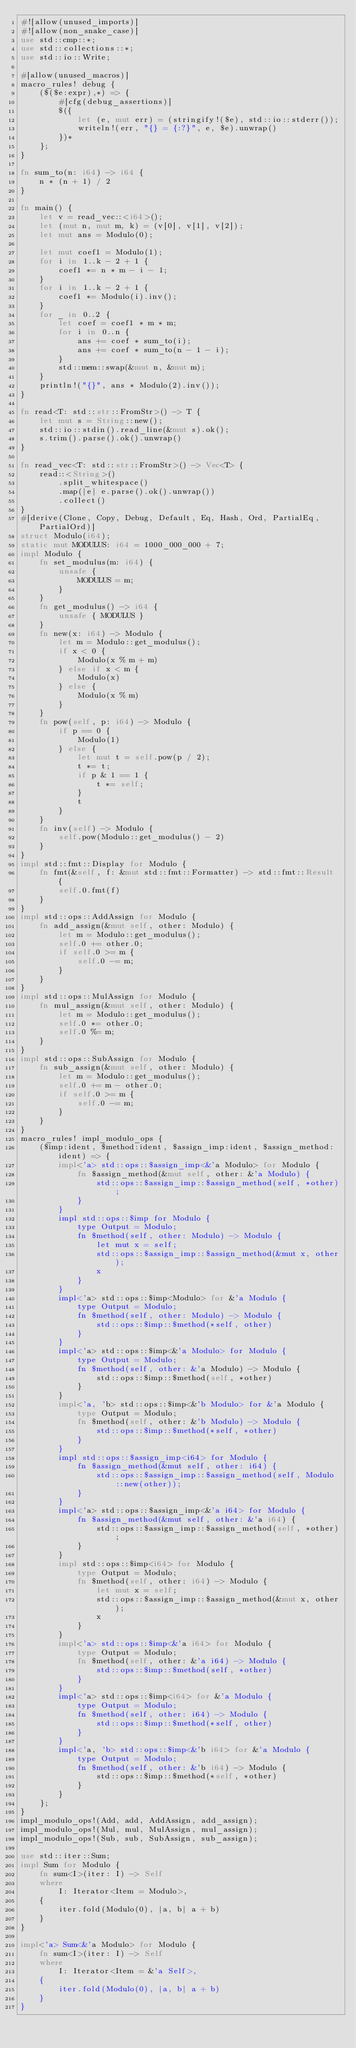Convert code to text. <code><loc_0><loc_0><loc_500><loc_500><_Rust_>#![allow(unused_imports)]
#![allow(non_snake_case)]
use std::cmp::*;
use std::collections::*;
use std::io::Write;

#[allow(unused_macros)]
macro_rules! debug {
    ($($e:expr),*) => {
        #[cfg(debug_assertions)]
        $({
            let (e, mut err) = (stringify!($e), std::io::stderr());
            writeln!(err, "{} = {:?}", e, $e).unwrap()
        })*
    };
}

fn sum_to(n: i64) -> i64 {
    n * (n + 1) / 2
}

fn main() {
    let v = read_vec::<i64>();
    let (mut n, mut m, k) = (v[0], v[1], v[2]);
    let mut ans = Modulo(0);

    let mut coef1 = Modulo(1);
    for i in 1..k - 2 + 1 {
        coef1 *= n * m - i - 1;
    }
    for i in 1..k - 2 + 1 {
        coef1 *= Modulo(i).inv();
    }
    for _ in 0..2 {
        let coef = coef1 * m * m;
        for i in 0..n {
            ans += coef * sum_to(i);
            ans += coef * sum_to(n - 1 - i);
        }
        std::mem::swap(&mut n, &mut m);
    }
    println!("{}", ans * Modulo(2).inv());
}

fn read<T: std::str::FromStr>() -> T {
    let mut s = String::new();
    std::io::stdin().read_line(&mut s).ok();
    s.trim().parse().ok().unwrap()
}

fn read_vec<T: std::str::FromStr>() -> Vec<T> {
    read::<String>()
        .split_whitespace()
        .map(|e| e.parse().ok().unwrap())
        .collect()
}
#[derive(Clone, Copy, Debug, Default, Eq, Hash, Ord, PartialEq, PartialOrd)]
struct Modulo(i64);
static mut MODULUS: i64 = 1000_000_000 + 7;
impl Modulo {
    fn set_modulus(m: i64) {
        unsafe {
            MODULUS = m;
        }
    }
    fn get_modulus() -> i64 {
        unsafe { MODULUS }
    }
    fn new(x: i64) -> Modulo {
        let m = Modulo::get_modulus();
        if x < 0 {
            Modulo(x % m + m)
        } else if x < m {
            Modulo(x)
        } else {
            Modulo(x % m)
        }
    }
    fn pow(self, p: i64) -> Modulo {
        if p == 0 {
            Modulo(1)
        } else {
            let mut t = self.pow(p / 2);
            t *= t;
            if p & 1 == 1 {
                t *= self;
            }
            t
        }
    }
    fn inv(self) -> Modulo {
        self.pow(Modulo::get_modulus() - 2)
    }
}
impl std::fmt::Display for Modulo {
    fn fmt(&self, f: &mut std::fmt::Formatter) -> std::fmt::Result {
        self.0.fmt(f)
    }
}
impl std::ops::AddAssign for Modulo {
    fn add_assign(&mut self, other: Modulo) {
        let m = Modulo::get_modulus();
        self.0 += other.0;
        if self.0 >= m {
            self.0 -= m;
        }
    }
}
impl std::ops::MulAssign for Modulo {
    fn mul_assign(&mut self, other: Modulo) {
        let m = Modulo::get_modulus();
        self.0 *= other.0;
        self.0 %= m;
    }
}
impl std::ops::SubAssign for Modulo {
    fn sub_assign(&mut self, other: Modulo) {
        let m = Modulo::get_modulus();
        self.0 += m - other.0;
        if self.0 >= m {
            self.0 -= m;
        }
    }
}
macro_rules! impl_modulo_ops {
    ($imp:ident, $method:ident, $assign_imp:ident, $assign_method:ident) => {
        impl<'a> std::ops::$assign_imp<&'a Modulo> for Modulo {
            fn $assign_method(&mut self, other: &'a Modulo) {
                std::ops::$assign_imp::$assign_method(self, *other);
            }
        }
        impl std::ops::$imp for Modulo {
            type Output = Modulo;
            fn $method(self, other: Modulo) -> Modulo {
                let mut x = self;
                std::ops::$assign_imp::$assign_method(&mut x, other);
                x
            }
        }
        impl<'a> std::ops::$imp<Modulo> for &'a Modulo {
            type Output = Modulo;
            fn $method(self, other: Modulo) -> Modulo {
                std::ops::$imp::$method(*self, other)
            }
        }
        impl<'a> std::ops::$imp<&'a Modulo> for Modulo {
            type Output = Modulo;
            fn $method(self, other: &'a Modulo) -> Modulo {
                std::ops::$imp::$method(self, *other)
            }
        }
        impl<'a, 'b> std::ops::$imp<&'b Modulo> for &'a Modulo {
            type Output = Modulo;
            fn $method(self, other: &'b Modulo) -> Modulo {
                std::ops::$imp::$method(*self, *other)
            }
        }
        impl std::ops::$assign_imp<i64> for Modulo {
            fn $assign_method(&mut self, other: i64) {
                std::ops::$assign_imp::$assign_method(self, Modulo::new(other));
            }
        }
        impl<'a> std::ops::$assign_imp<&'a i64> for Modulo {
            fn $assign_method(&mut self, other: &'a i64) {
                std::ops::$assign_imp::$assign_method(self, *other);
            }
        }
        impl std::ops::$imp<i64> for Modulo {
            type Output = Modulo;
            fn $method(self, other: i64) -> Modulo {
                let mut x = self;
                std::ops::$assign_imp::$assign_method(&mut x, other);
                x
            }
        }
        impl<'a> std::ops::$imp<&'a i64> for Modulo {
            type Output = Modulo;
            fn $method(self, other: &'a i64) -> Modulo {
                std::ops::$imp::$method(self, *other)
            }
        }
        impl<'a> std::ops::$imp<i64> for &'a Modulo {
            type Output = Modulo;
            fn $method(self, other: i64) -> Modulo {
                std::ops::$imp::$method(*self, other)
            }
        }
        impl<'a, 'b> std::ops::$imp<&'b i64> for &'a Modulo {
            type Output = Modulo;
            fn $method(self, other: &'b i64) -> Modulo {
                std::ops::$imp::$method(*self, *other)
            }
        }
    };
}
impl_modulo_ops!(Add, add, AddAssign, add_assign);
impl_modulo_ops!(Mul, mul, MulAssign, mul_assign);
impl_modulo_ops!(Sub, sub, SubAssign, sub_assign);

use std::iter::Sum;
impl Sum for Modulo {
    fn sum<I>(iter: I) -> Self
    where
        I: Iterator<Item = Modulo>,
    {
        iter.fold(Modulo(0), |a, b| a + b)
    }
}

impl<'a> Sum<&'a Modulo> for Modulo {
    fn sum<I>(iter: I) -> Self
    where
        I: Iterator<Item = &'a Self>,
    {
        iter.fold(Modulo(0), |a, b| a + b)
    }
}
</code> 